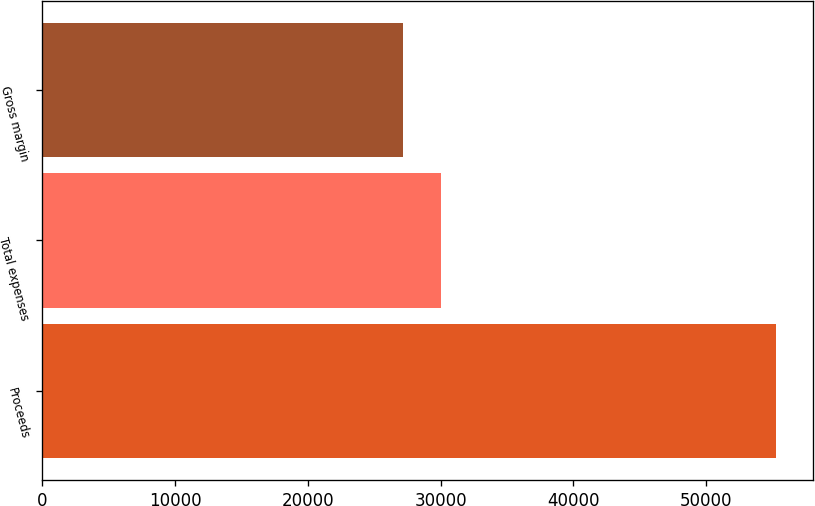Convert chart. <chart><loc_0><loc_0><loc_500><loc_500><bar_chart><fcel>Proceeds<fcel>Total expenses<fcel>Gross margin<nl><fcel>55261<fcel>30000.7<fcel>27194<nl></chart> 